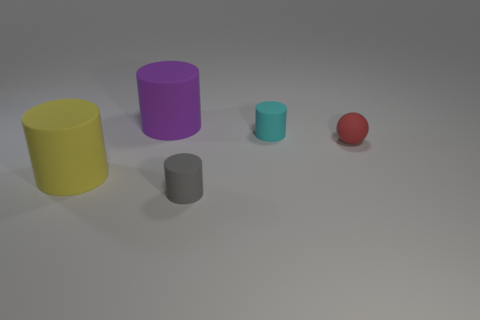Is the number of tiny balls less than the number of matte cylinders? Yes, indeed. In the image, there is only one small ball present, while there are three matte cylinders visible, making the count of tiny balls less than the number of matte cylinders. 